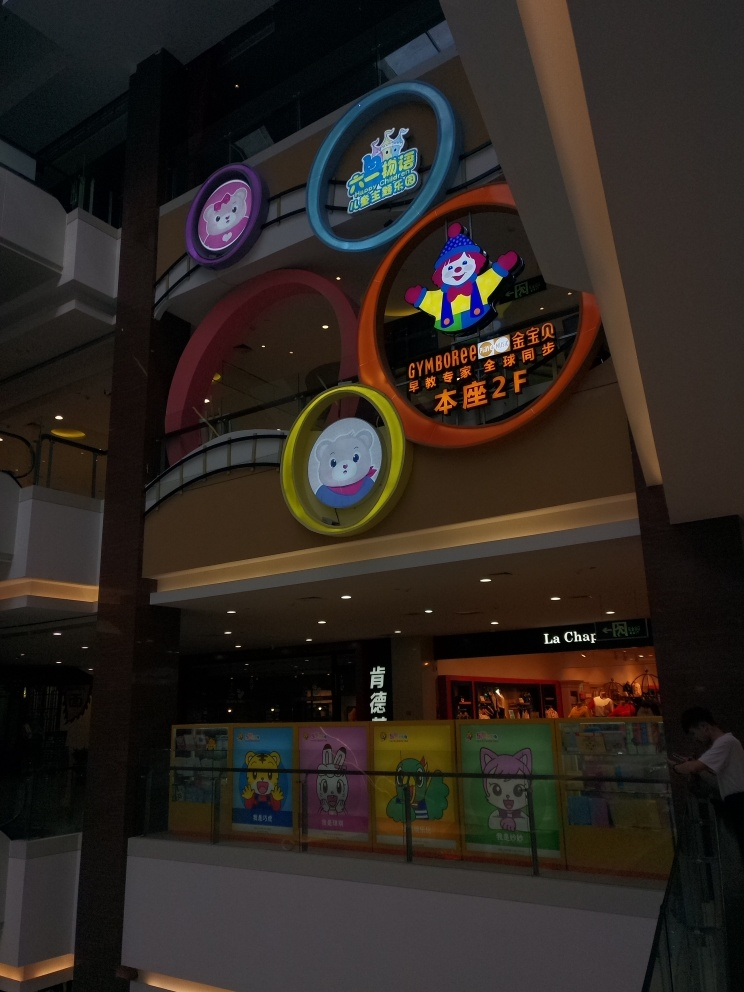What can be said about the quality of the image?
A. Superb
B. Good
C. Average
Answer with the option's letter from the given choices directly. The quality of the image can be considered as 'Good' (Option B). Although the lighting conditions create some dark areas, the main subjects—the colorful shopfront and signage—are clear and discernible. Additionally, the image is in focus and the resolution is adequate for recognizing the playful design and branding of the shops. 